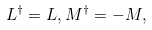<formula> <loc_0><loc_0><loc_500><loc_500>L ^ { \dagger } = L , M ^ { \dagger } = - M ,</formula> 